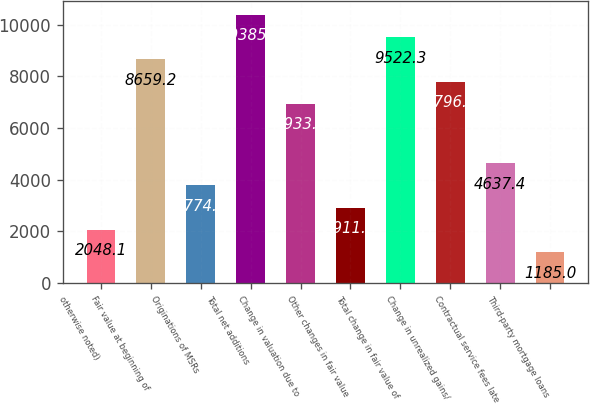<chart> <loc_0><loc_0><loc_500><loc_500><bar_chart><fcel>otherwise noted)<fcel>Fair value at beginning of<fcel>Originations of MSRs<fcel>Total net additions<fcel>Change in valuation due to<fcel>Other changes in fair value<fcel>Total change in fair value of<fcel>Change in unrealized gains/<fcel>Contractual service fees late<fcel>Third-party mortgage loans<nl><fcel>2048.1<fcel>8659.2<fcel>3774.3<fcel>10385.4<fcel>6933<fcel>2911.2<fcel>9522.3<fcel>7796.1<fcel>4637.4<fcel>1185<nl></chart> 